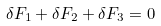Convert formula to latex. <formula><loc_0><loc_0><loc_500><loc_500>\delta F _ { 1 } + \delta F _ { 2 } + \delta F _ { 3 } = 0</formula> 